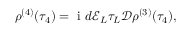Convert formula to latex. <formula><loc_0><loc_0><loc_500><loc_500>\rho ^ { ( 4 ) } ( \tau _ { 4 } ) = { i } d \mathcal { E } _ { L } \tau _ { L } \ m a t h s c r { D } \rho ^ { ( 3 ) } ( \tau _ { 4 } ) ,</formula> 